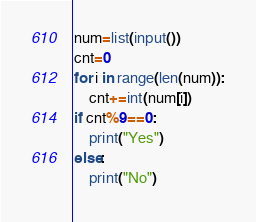<code> <loc_0><loc_0><loc_500><loc_500><_Python_>num=list(input())
cnt=0
for i in range(len(num)):
    cnt+=int(num[i])
if cnt%9==0:
    print("Yes")
else:
    print("No")
</code> 